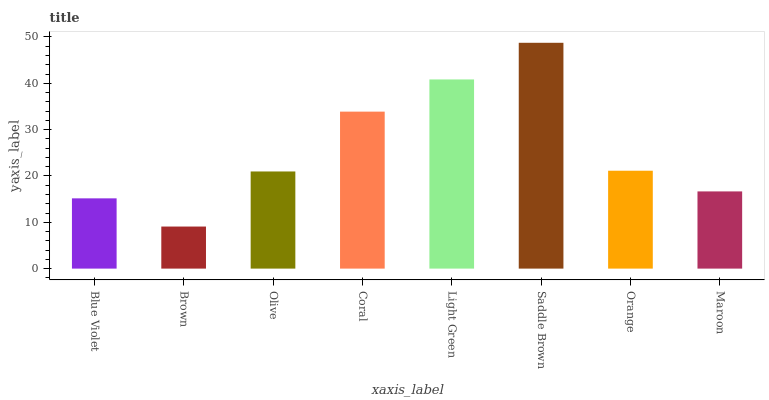Is Brown the minimum?
Answer yes or no. Yes. Is Saddle Brown the maximum?
Answer yes or no. Yes. Is Olive the minimum?
Answer yes or no. No. Is Olive the maximum?
Answer yes or no. No. Is Olive greater than Brown?
Answer yes or no. Yes. Is Brown less than Olive?
Answer yes or no. Yes. Is Brown greater than Olive?
Answer yes or no. No. Is Olive less than Brown?
Answer yes or no. No. Is Orange the high median?
Answer yes or no. Yes. Is Olive the low median?
Answer yes or no. Yes. Is Saddle Brown the high median?
Answer yes or no. No. Is Maroon the low median?
Answer yes or no. No. 